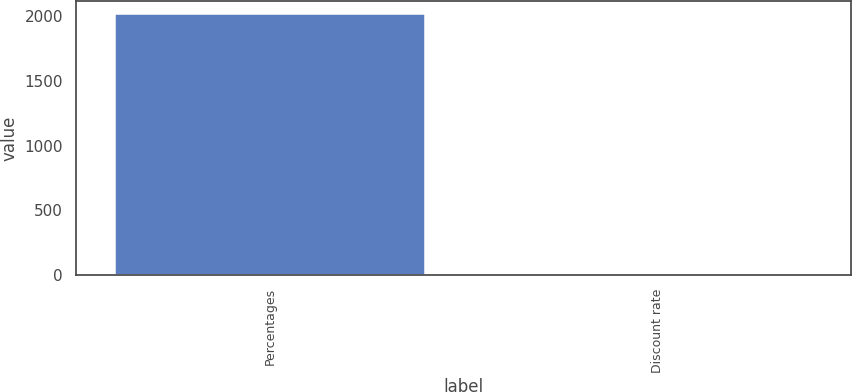Convert chart. <chart><loc_0><loc_0><loc_500><loc_500><bar_chart><fcel>Percentages<fcel>Discount rate<nl><fcel>2014<fcel>3.74<nl></chart> 